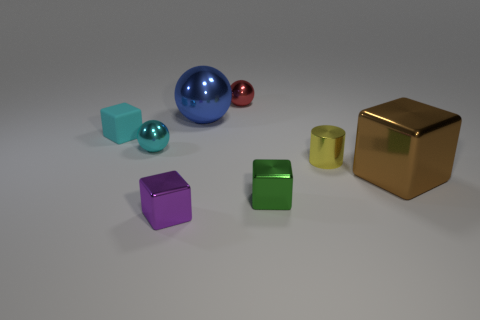Is the number of tiny cyan things to the left of the small rubber object less than the number of tiny red shiny balls?
Your answer should be very brief. Yes. What is the size of the block to the right of the green cube?
Ensure brevity in your answer.  Large. There is another small shiny thing that is the same shape as the tiny red thing; what is its color?
Offer a terse response. Cyan. How many tiny shiny balls are the same color as the small matte object?
Offer a very short reply. 1. Are there any other things that are the same shape as the small yellow shiny thing?
Keep it short and to the point. No. There is a block that is behind the metallic thing to the right of the tiny yellow shiny cylinder; is there a small cylinder that is to the left of it?
Provide a short and direct response. No. How many tiny cyan blocks are made of the same material as the large block?
Ensure brevity in your answer.  0. There is a sphere to the left of the small purple thing; is its size the same as the metallic cube that is to the right of the yellow object?
Offer a terse response. No. What color is the large metal object behind the large metallic object in front of the tiny block behind the small yellow shiny cylinder?
Your answer should be compact. Blue. Is there another metallic object that has the same shape as the red thing?
Make the answer very short. Yes. 